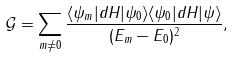<formula> <loc_0><loc_0><loc_500><loc_500>\mathcal { G } = \sum _ { m \neq 0 } \frac { \langle \psi _ { m } | d H | \psi _ { 0 } \rangle \langle \psi _ { 0 } | d H | \psi \rangle } { ( E _ { m } - E _ { 0 } ) ^ { 2 } } ,</formula> 